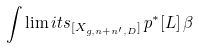<formula> <loc_0><loc_0><loc_500><loc_500>\int \lim i t s _ { [ X _ { g , n + n ^ { \prime } , D } ] } \, p ^ { * } [ L ] \, \beta</formula> 